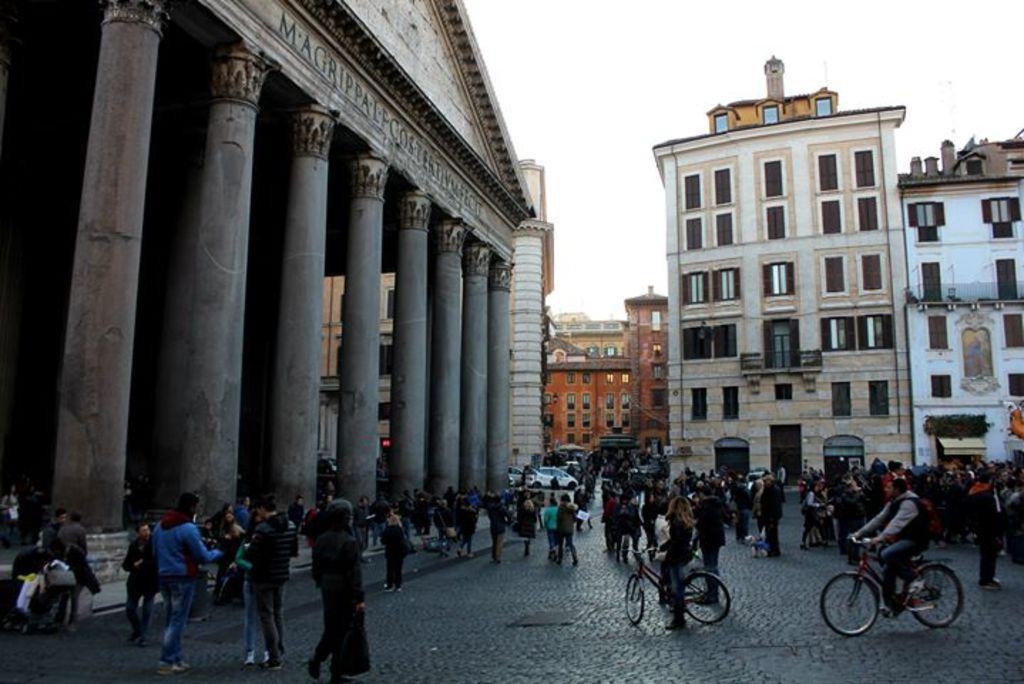Can you describe this image briefly? Here in this picture on the left side we can see a pantheon present and beside that we can see number of houses and buildings present and on the ground we can see number of people standing and walking and we can see some people are riding bicycles and some people are carrying bags with them and we can also see cars present on the road and we can see the sky is clear. 